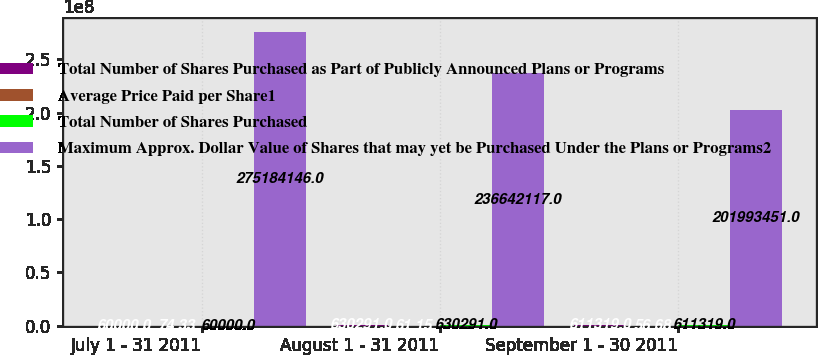<chart> <loc_0><loc_0><loc_500><loc_500><stacked_bar_chart><ecel><fcel>July 1 - 31 2011<fcel>August 1 - 31 2011<fcel>September 1 - 30 2011<nl><fcel>Total Number of Shares Purchased as Part of Publicly Announced Plans or Programs<fcel>60000<fcel>630291<fcel>611319<nl><fcel>Average Price Paid per Share1<fcel>74.33<fcel>61.15<fcel>56.68<nl><fcel>Total Number of Shares Purchased<fcel>60000<fcel>630291<fcel>611319<nl><fcel>Maximum Approx. Dollar Value of Shares that may yet be Purchased Under the Plans or Programs2<fcel>2.75184e+08<fcel>2.36642e+08<fcel>2.01993e+08<nl></chart> 